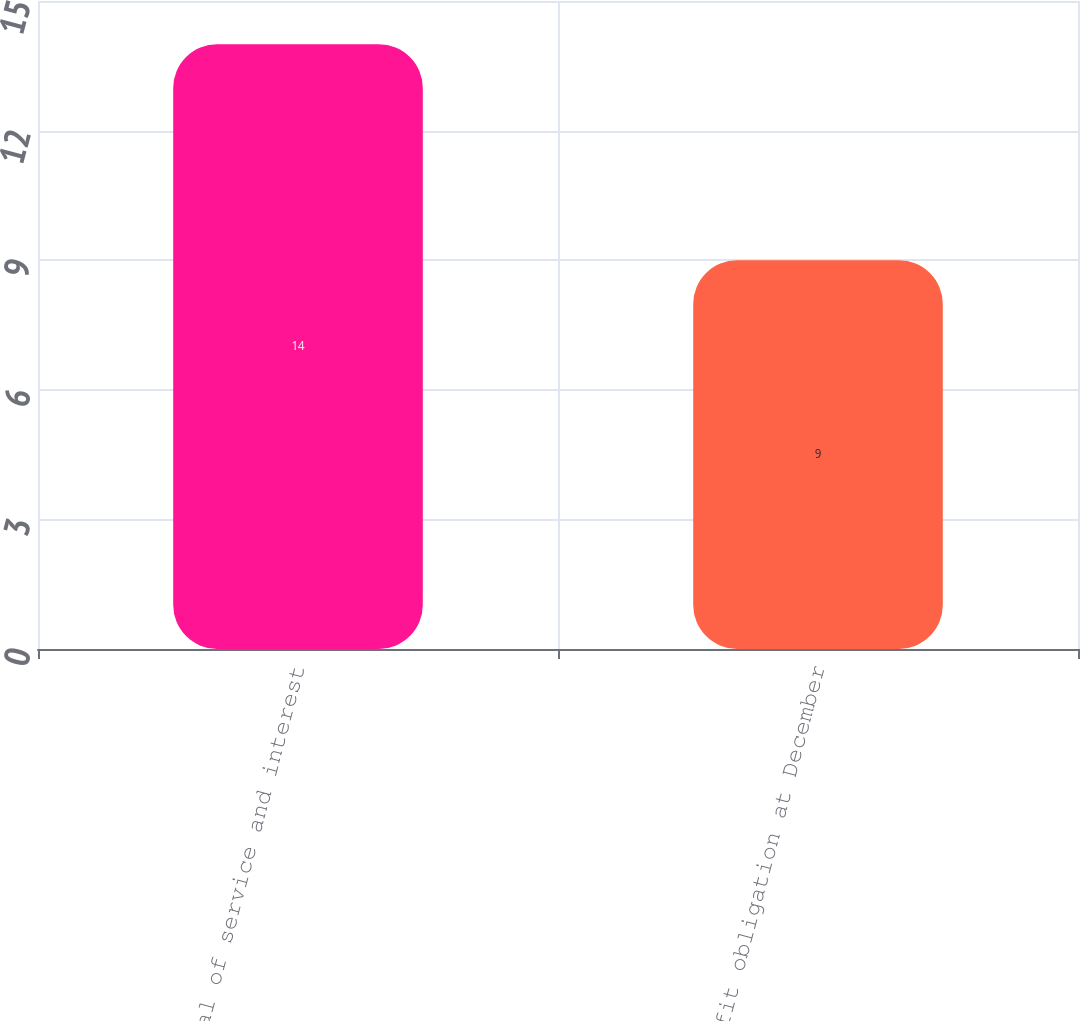<chart> <loc_0><loc_0><loc_500><loc_500><bar_chart><fcel>Total of service and interest<fcel>Benefit obligation at December<nl><fcel>14<fcel>9<nl></chart> 